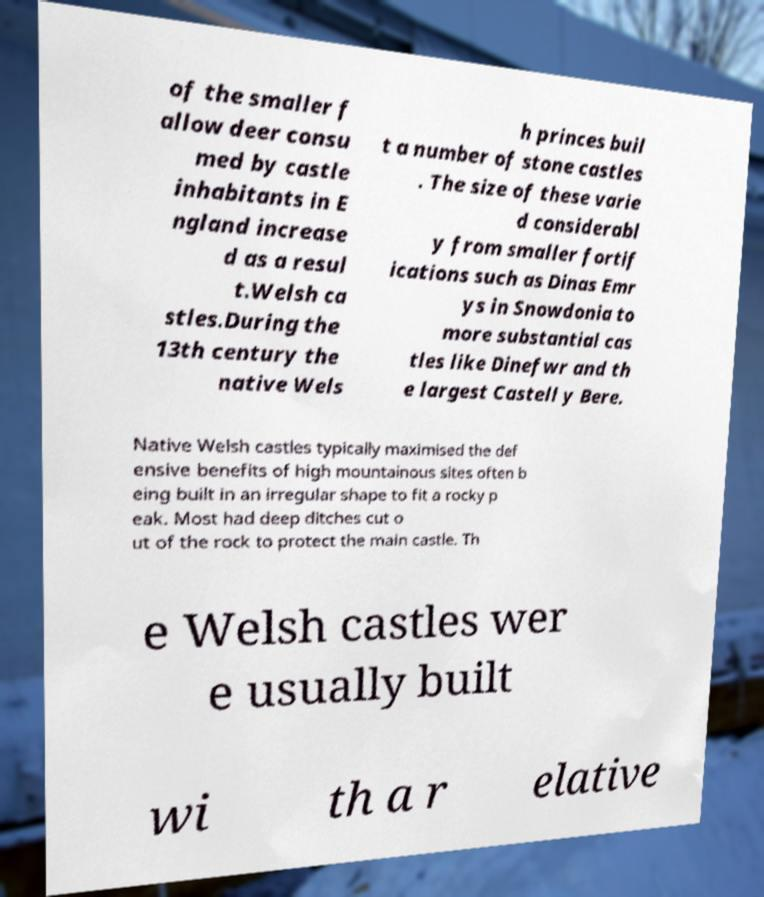Please identify and transcribe the text found in this image. of the smaller f allow deer consu med by castle inhabitants in E ngland increase d as a resul t.Welsh ca stles.During the 13th century the native Wels h princes buil t a number of stone castles . The size of these varie d considerabl y from smaller fortif ications such as Dinas Emr ys in Snowdonia to more substantial cas tles like Dinefwr and th e largest Castell y Bere. Native Welsh castles typically maximised the def ensive benefits of high mountainous sites often b eing built in an irregular shape to fit a rocky p eak. Most had deep ditches cut o ut of the rock to protect the main castle. Th e Welsh castles wer e usually built wi th a r elative 